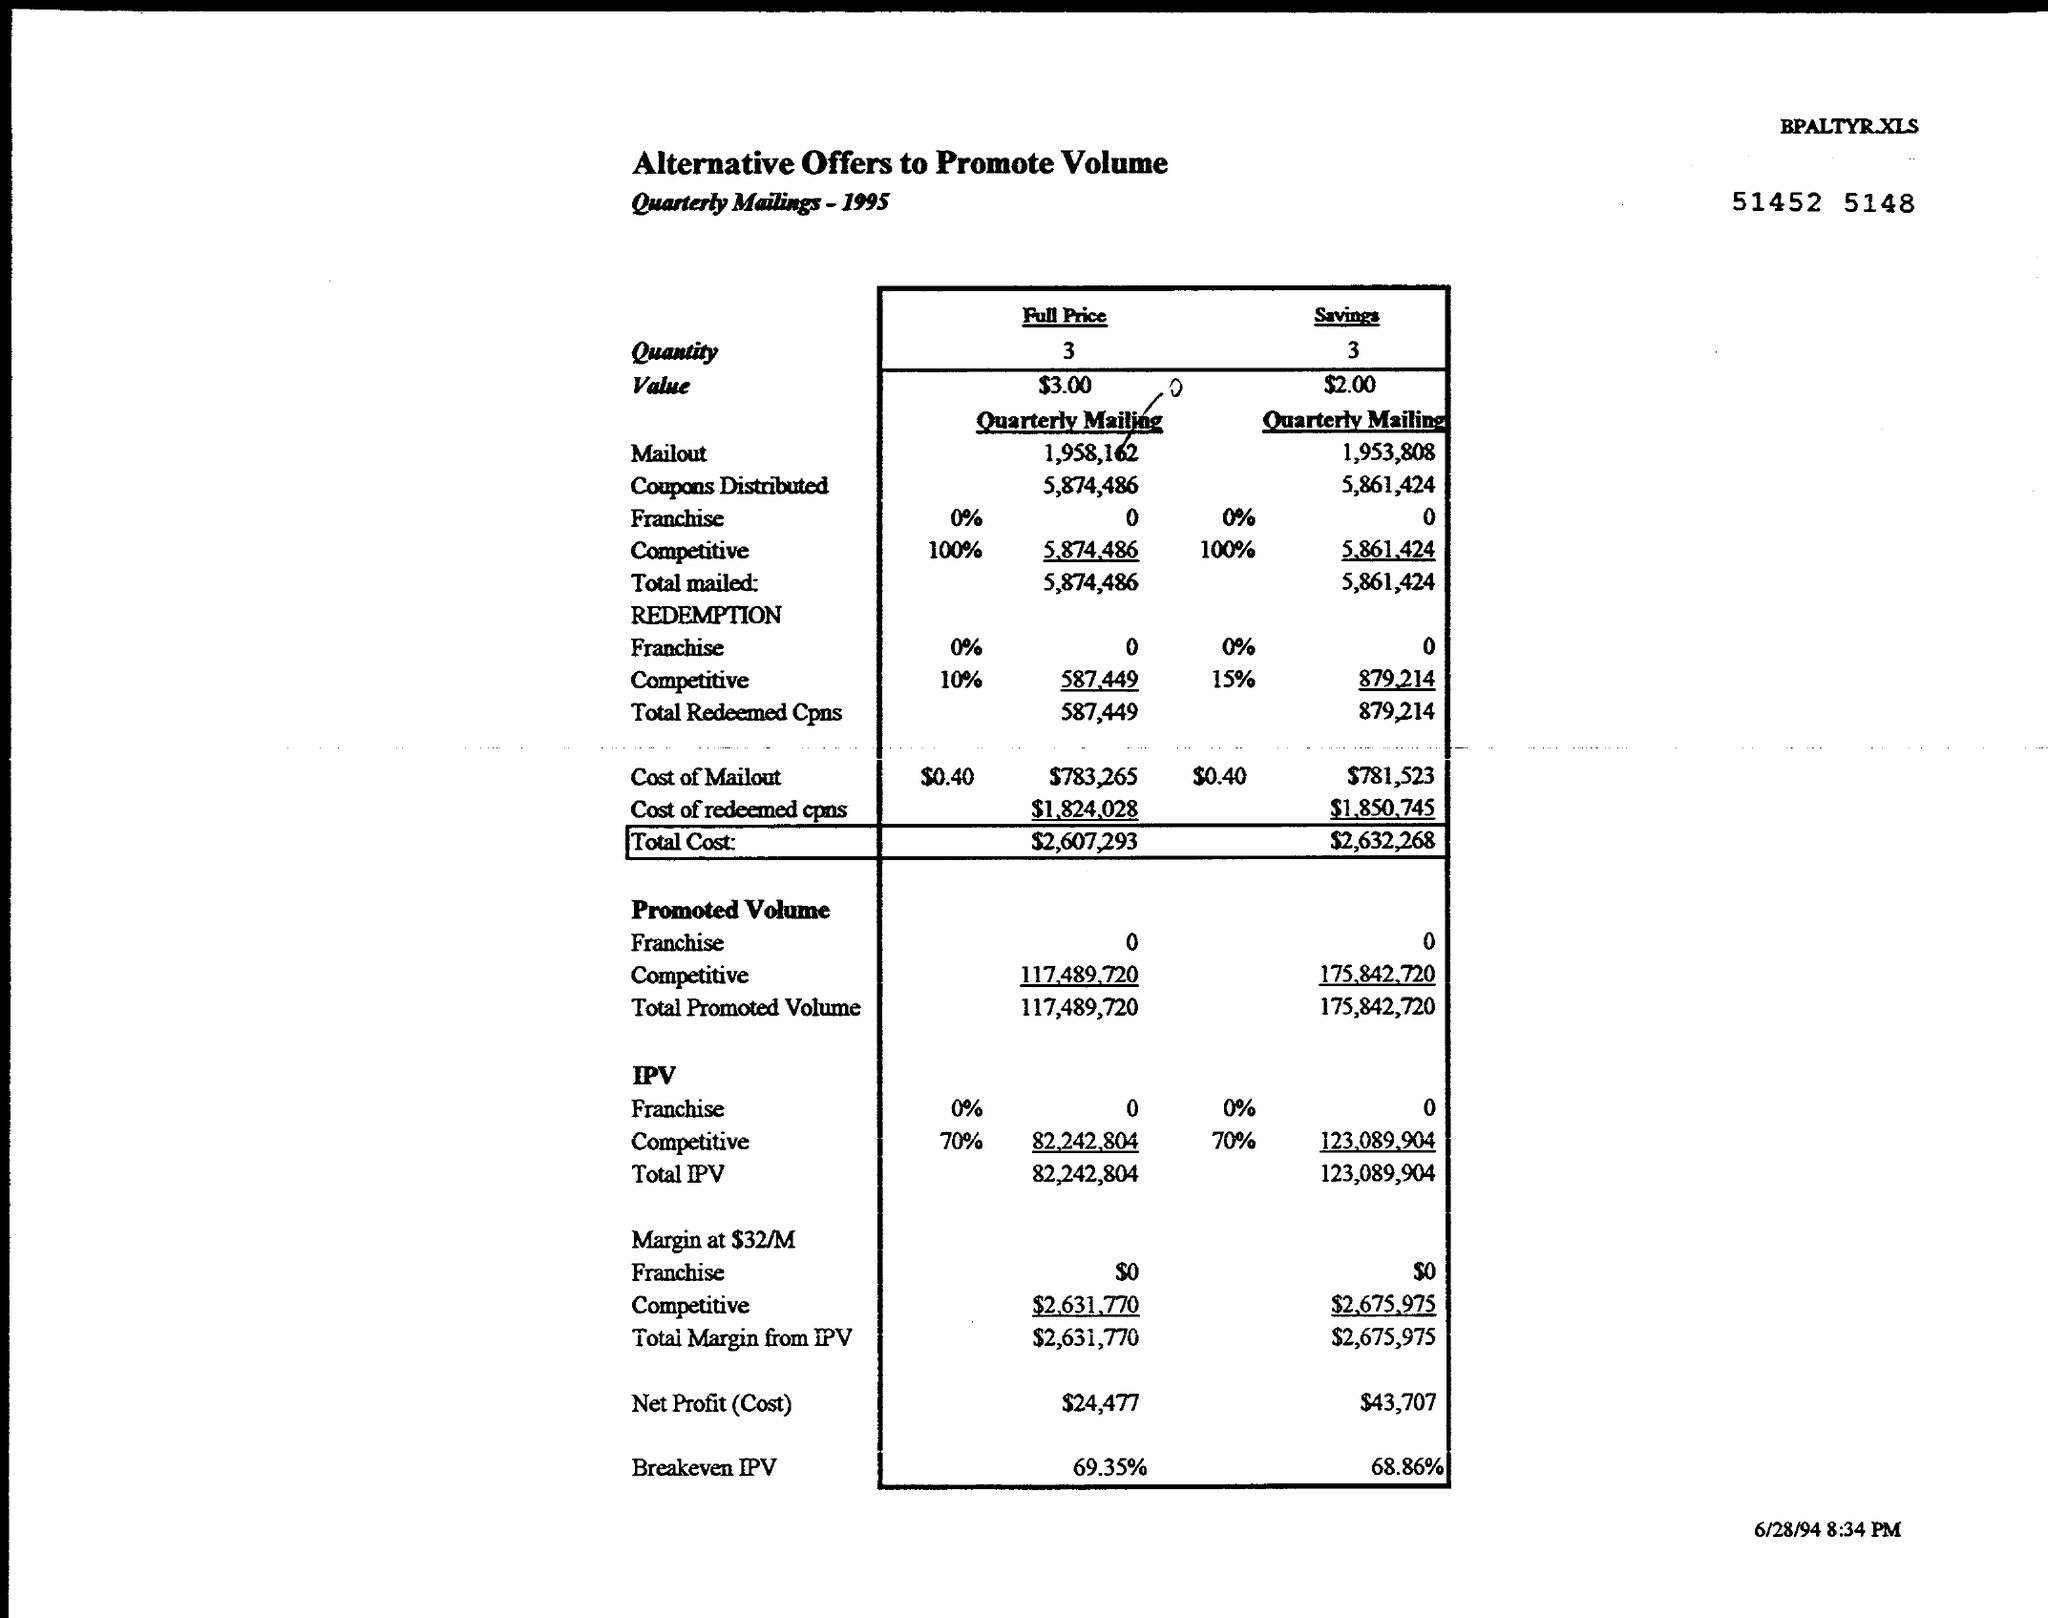What is the Title of the document?
Provide a succinct answer. Alternative Offers to Promote Volume. How much is the "Full Price" "Quantity"?
Your answer should be compact. 3. How much is the "Savings" "Quantity"?
Offer a terse response. 3. How much is the "Full Price" "Value"?
Provide a short and direct response. $3.00. How much is the "Savings" "Value"?
Provide a short and direct response. $2.00. How much is the "Savings" "Total Cost"?
Provide a succinct answer. $2,632,268. How much is the "Savings" "Net Profit (Cost)"?
Give a very brief answer. $43,707. 